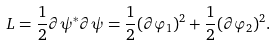<formula> <loc_0><loc_0><loc_500><loc_500>L = \frac { 1 } { 2 } \partial \psi ^ { * } \partial \psi = \frac { 1 } { 2 } ( \partial \varphi _ { 1 } ) ^ { 2 } + \frac { 1 } { 2 } ( \partial \varphi _ { 2 } ) ^ { 2 } .</formula> 